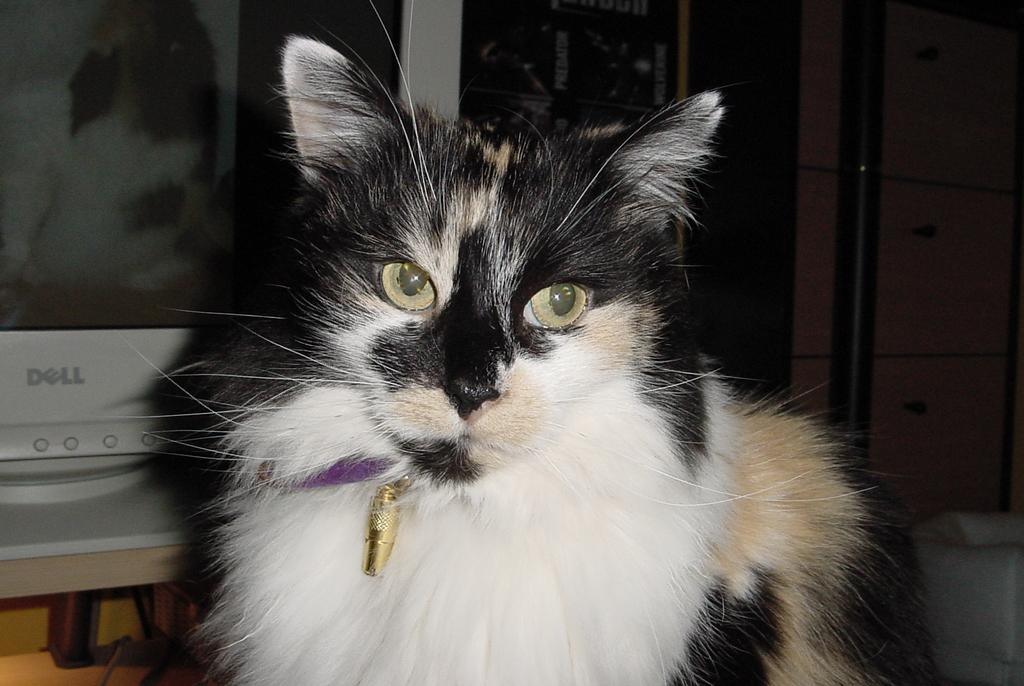<image>
Write a terse but informative summary of the picture. A fluffy cat is sitting in front of a Dell monitor. 